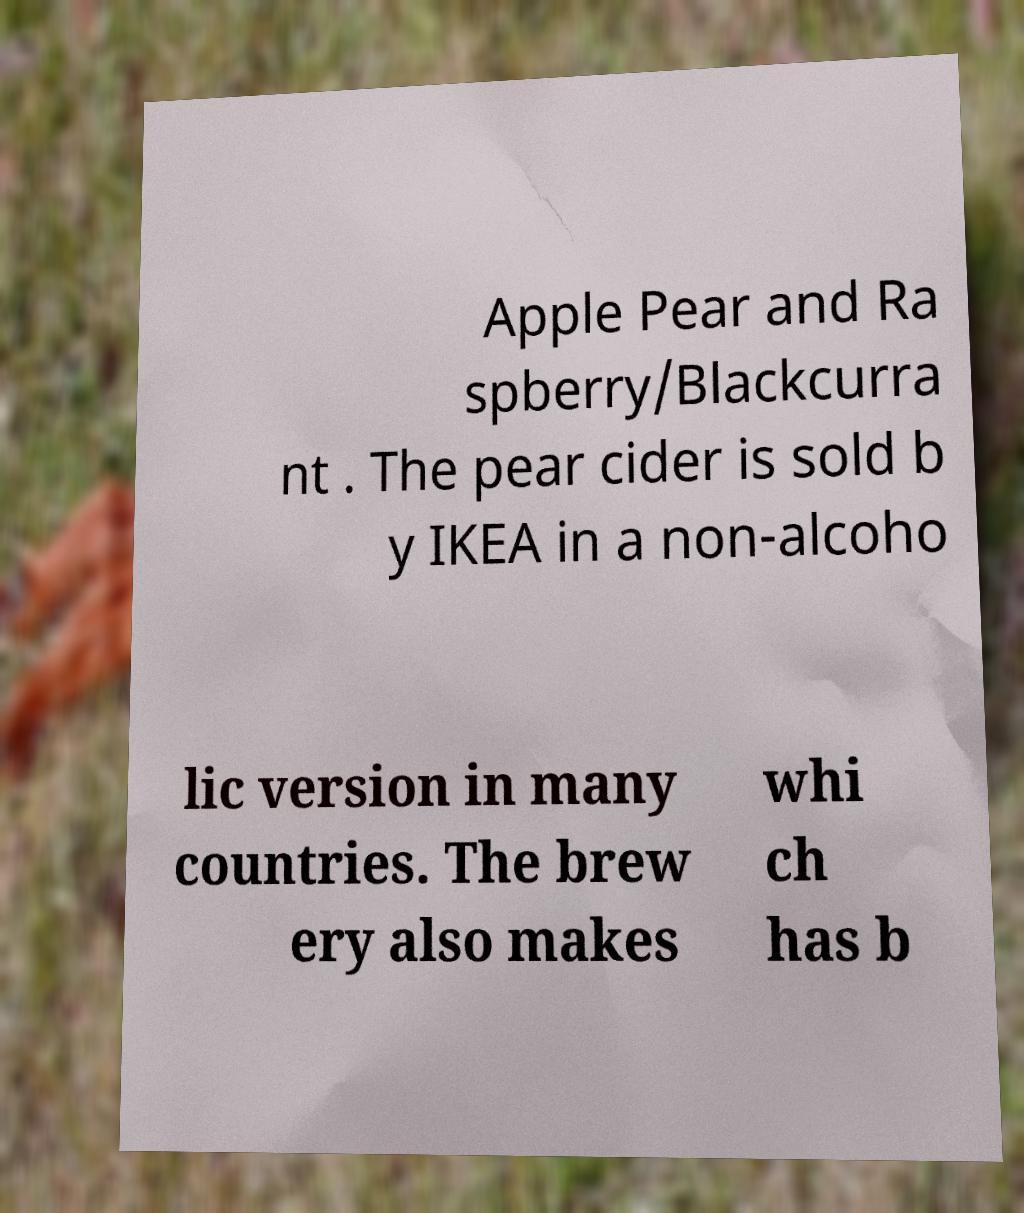Please read and relay the text visible in this image. What does it say? Apple Pear and Ra spberry/Blackcurra nt . The pear cider is sold b y IKEA in a non-alcoho lic version in many countries. The brew ery also makes whi ch has b 